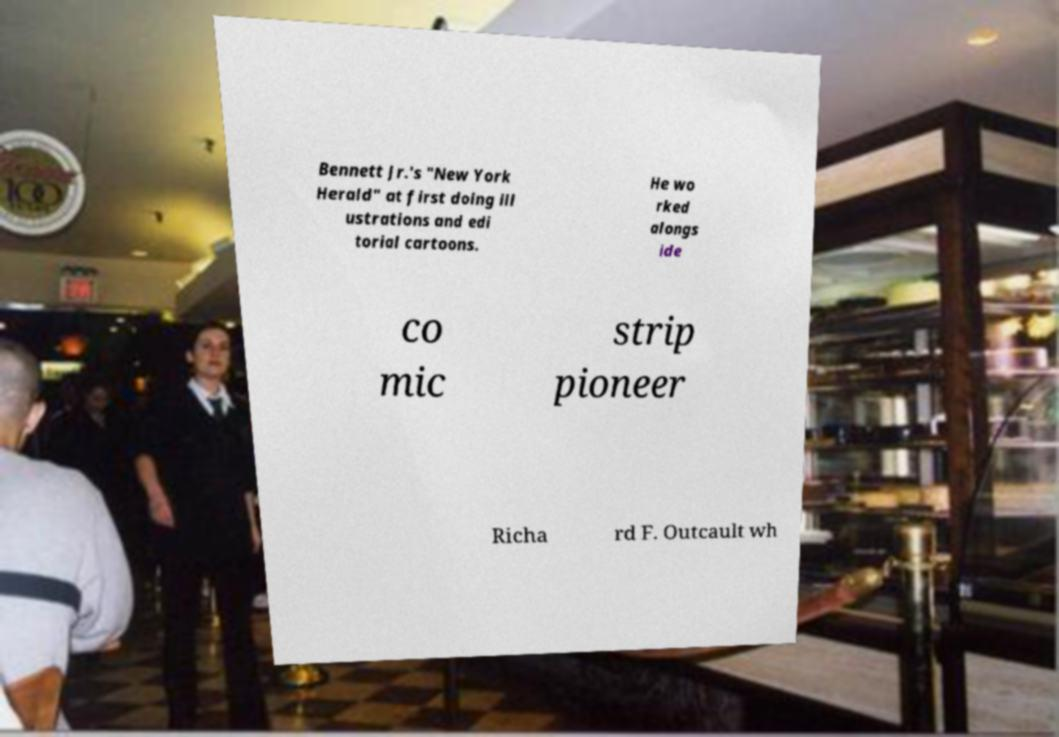Can you read and provide the text displayed in the image?This photo seems to have some interesting text. Can you extract and type it out for me? Bennett Jr.'s "New York Herald" at first doing ill ustrations and edi torial cartoons. He wo rked alongs ide co mic strip pioneer Richa rd F. Outcault wh 